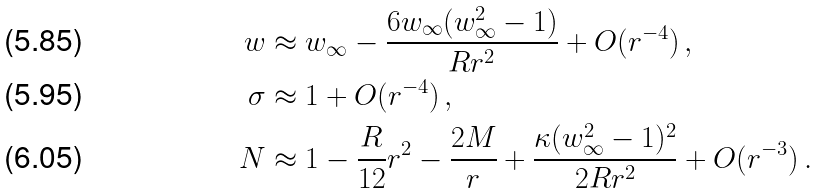Convert formula to latex. <formula><loc_0><loc_0><loc_500><loc_500>w & \approx w _ { \infty } - \frac { 6 w _ { \infty } ( w _ { \infty } ^ { 2 } - 1 ) } { R r ^ { 2 } } + O ( r ^ { - 4 } ) \, , \\ \sigma & \approx 1 + O ( r ^ { - 4 } ) \, , \\ N & \approx 1 - \frac { R } { 1 2 } r ^ { 2 } - \frac { 2 M } { r } + \frac { \kappa ( w _ { \infty } ^ { 2 } - 1 ) ^ { 2 } } { 2 R r ^ { 2 } } + O ( r ^ { - 3 } ) \, .</formula> 